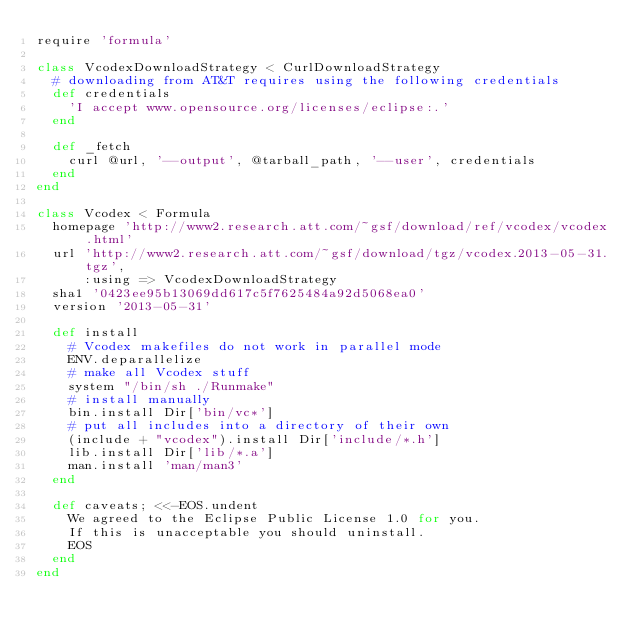<code> <loc_0><loc_0><loc_500><loc_500><_Ruby_>require 'formula'

class VcodexDownloadStrategy < CurlDownloadStrategy
  # downloading from AT&T requires using the following credentials
  def credentials
    'I accept www.opensource.org/licenses/eclipse:.'
  end

  def _fetch
    curl @url, '--output', @tarball_path, '--user', credentials
  end
end

class Vcodex < Formula
  homepage 'http://www2.research.att.com/~gsf/download/ref/vcodex/vcodex.html'
  url 'http://www2.research.att.com/~gsf/download/tgz/vcodex.2013-05-31.tgz',
      :using => VcodexDownloadStrategy
  sha1 '0423ee95b13069dd617c5f7625484a92d5068ea0'
  version '2013-05-31'

  def install
    # Vcodex makefiles do not work in parallel mode
    ENV.deparallelize
    # make all Vcodex stuff
    system "/bin/sh ./Runmake"
    # install manually
    bin.install Dir['bin/vc*']
    # put all includes into a directory of their own
    (include + "vcodex").install Dir['include/*.h']
    lib.install Dir['lib/*.a']
    man.install 'man/man3'
  end

  def caveats; <<-EOS.undent
    We agreed to the Eclipse Public License 1.0 for you.
    If this is unacceptable you should uninstall.
    EOS
  end
end
</code> 